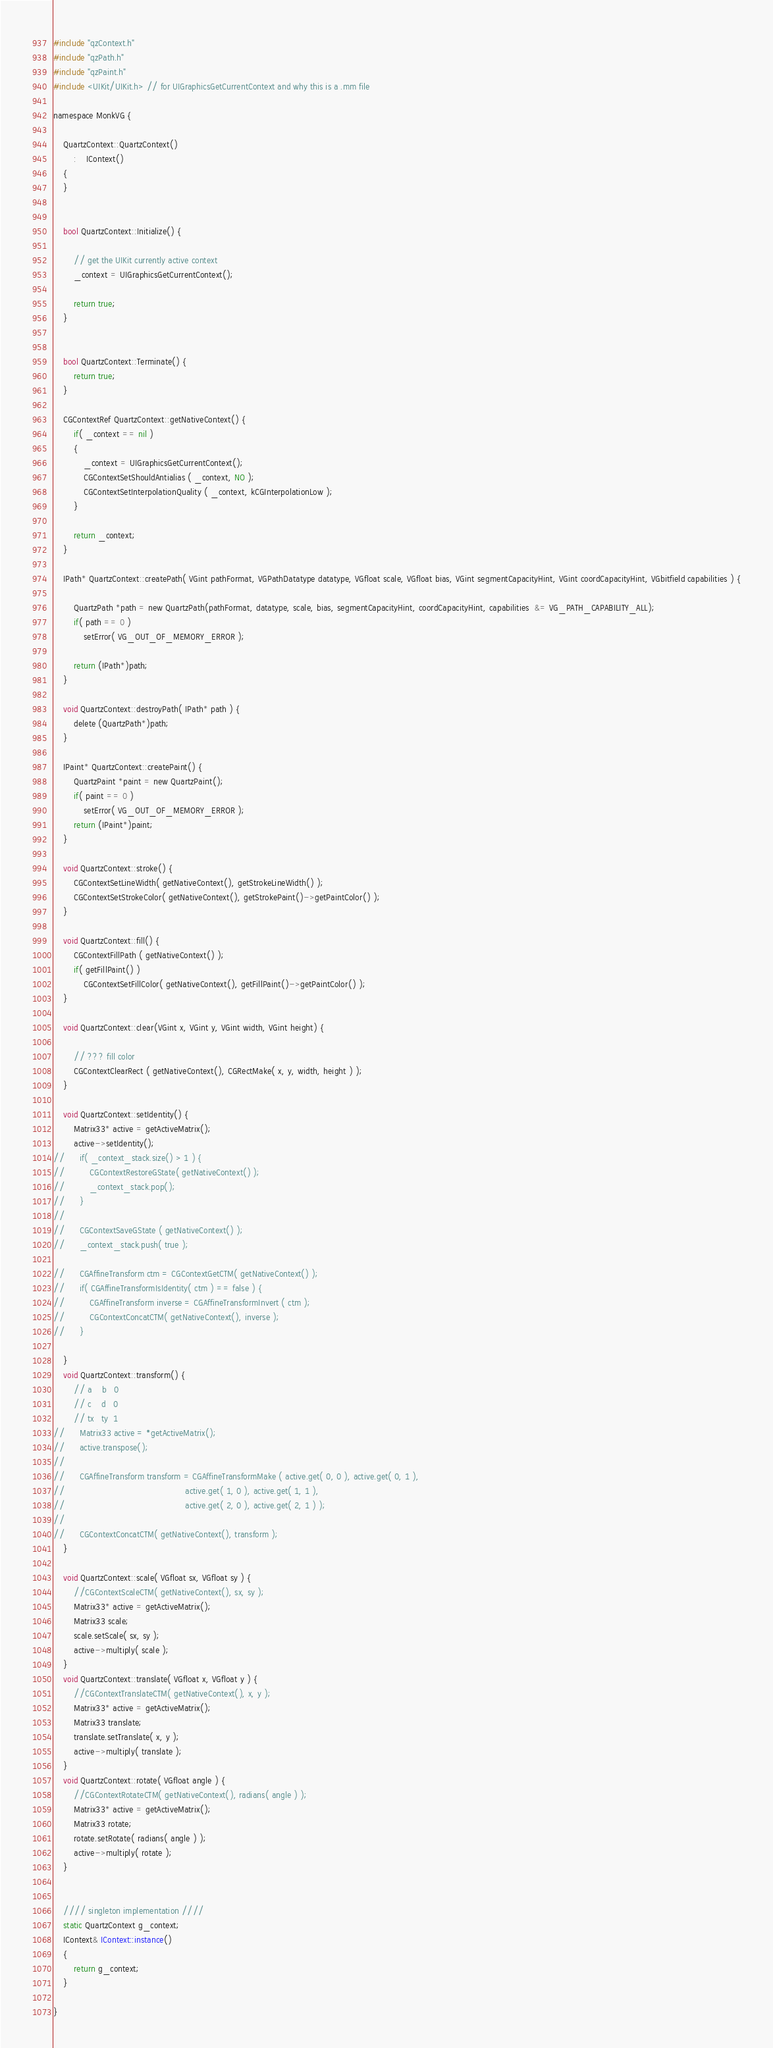Convert code to text. <code><loc_0><loc_0><loc_500><loc_500><_ObjectiveC_>#include "qzContext.h"
#include "qzPath.h"
#include "qzPaint.h"
#include <UIKit/UIKit.h> // for UIGraphicsGetCurrentContext and why this is a .mm file

namespace MonkVG {
	
	QuartzContext::QuartzContext()
		:	IContext()
	{
	}
	
	
	bool QuartzContext::Initialize() {
	
		// get the UIKit currently active context
		_context = UIGraphicsGetCurrentContext();

		return true;
	}
	
	
	bool QuartzContext::Terminate() {
		return true;
	}
	
	CGContextRef QuartzContext::getNativeContext() {
		if( _context == nil )
		{
			_context = UIGraphicsGetCurrentContext();
			CGContextSetShouldAntialias ( _context, NO );
			CGContextSetInterpolationQuality ( _context, kCGInterpolationLow );
		}
		
		return _context;
	}
	
	IPath* QuartzContext::createPath( VGint pathFormat, VGPathDatatype datatype, VGfloat scale, VGfloat bias, VGint segmentCapacityHint, VGint coordCapacityHint, VGbitfield capabilities ) {
	
		QuartzPath *path = new QuartzPath(pathFormat, datatype, scale, bias, segmentCapacityHint, coordCapacityHint, capabilities  &= VG_PATH_CAPABILITY_ALL);
		if( path == 0 )
			setError( VG_OUT_OF_MEMORY_ERROR );
	
		return (IPath*)path;
	}
	
	void QuartzContext::destroyPath( IPath* path ) {
		delete (QuartzPath*)path;
	}
	
	IPaint* QuartzContext::createPaint() {
		QuartzPaint *paint = new QuartzPaint();
		if( paint == 0 )
			setError( VG_OUT_OF_MEMORY_ERROR );
		return (IPaint*)paint;
	}
	
	void QuartzContext::stroke() {
		CGContextSetLineWidth( getNativeContext(), getStrokeLineWidth() );
		CGContextSetStrokeColor( getNativeContext(), getStrokePaint()->getPaintColor() );
	}
	
	void QuartzContext::fill() {
		CGContextFillPath ( getNativeContext() );
		if( getFillPaint() )
			CGContextSetFillColor( getNativeContext(), getFillPaint()->getPaintColor() );
	}
	
	void QuartzContext::clear(VGint x, VGint y, VGint width, VGint height) {
	
		// ??? fill color
		CGContextClearRect ( getNativeContext(), CGRectMake( x, y, width, height ) );
	}
	
	void QuartzContext::setIdentity() {
		Matrix33* active = getActiveMatrix();
		active->setIdentity();
//		if( _context_stack.size() > 1 ) {
//			CGContextRestoreGState( getNativeContext() );
//			_context_stack.pop(); 
//		}
//			
//		CGContextSaveGState ( getNativeContext() );
//		_context_stack.push( true );

//		CGAffineTransform ctm = CGContextGetCTM( getNativeContext() );
//		if( CGAffineTransformIsIdentity( ctm ) == false ) {
//			CGAffineTransform inverse = CGAffineTransformInvert ( ctm );
//			CGContextConcatCTM( getNativeContext(), inverse );
//		}

	}
	void QuartzContext::transform() {
		// a	b	0
		// c	d	0
		// tx	ty	1
//		Matrix33 active = *getActiveMatrix();
//		active.transpose();
//		
//		CGAffineTransform transform = CGAffineTransformMake ( active.get( 0, 0 ), active.get( 0, 1 ),
//												  active.get( 1, 0 ), active.get( 1, 1 ),
//												  active.get( 2, 0 ), active.get( 2, 1 ) );
//												  
//		CGContextConcatCTM( getNativeContext(), transform );
	}

	void QuartzContext::scale( VGfloat sx, VGfloat sy ) {
		//CGContextScaleCTM( getNativeContext(), sx, sy );
		Matrix33* active = getActiveMatrix();
		Matrix33 scale;
		scale.setScale( sx, sy );
		active->multiply( scale );
	}
	void QuartzContext::translate( VGfloat x, VGfloat y ) {
		//CGContextTranslateCTM( getNativeContext(), x, y );
		Matrix33* active = getActiveMatrix();
		Matrix33 translate;
		translate.setTranslate( x, y );
		active->multiply( translate );
	}
	void QuartzContext::rotate( VGfloat angle ) {
		//CGContextRotateCTM( getNativeContext(), radians( angle ) );
		Matrix33* active = getActiveMatrix();
		Matrix33 rotate;
		rotate.setRotate( radians( angle ) );
		active->multiply( rotate );
	}
	
	
	//// singleton implementation ////
	static QuartzContext g_context;
	IContext& IContext::instance()
	{
		return g_context;
	}
	
}</code> 